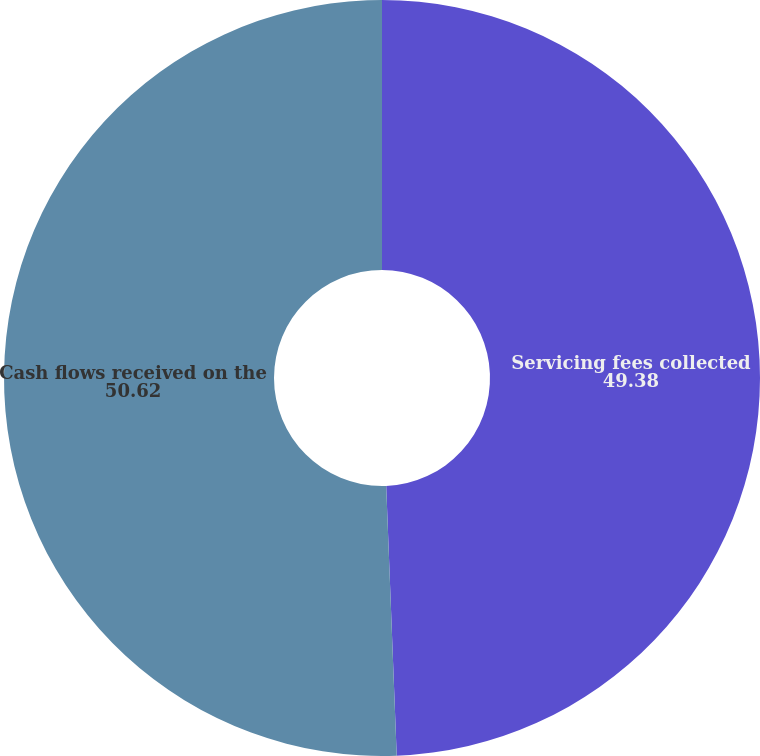<chart> <loc_0><loc_0><loc_500><loc_500><pie_chart><fcel>Servicing fees collected<fcel>Cash flows received on the<nl><fcel>49.38%<fcel>50.62%<nl></chart> 